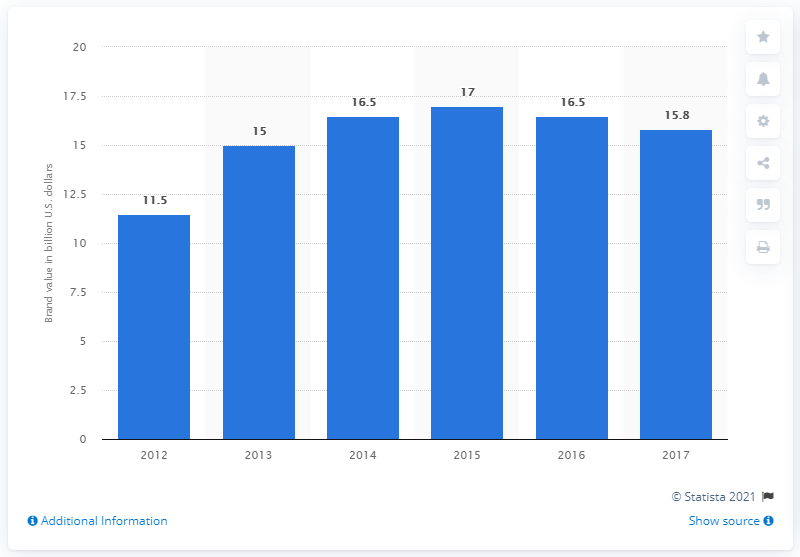Mention a couple of crucial points in this snapshot. In 2017, the brand value of ESPN was estimated to be 15.8 billion dollars. 